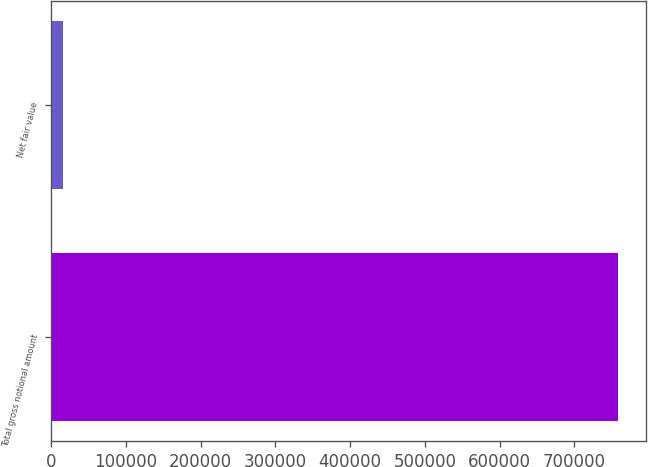Convert chart to OTSL. <chart><loc_0><loc_0><loc_500><loc_500><bar_chart><fcel>Total gross notional amount<fcel>Net fair value<nl><fcel>758246<fcel>15358<nl></chart> 